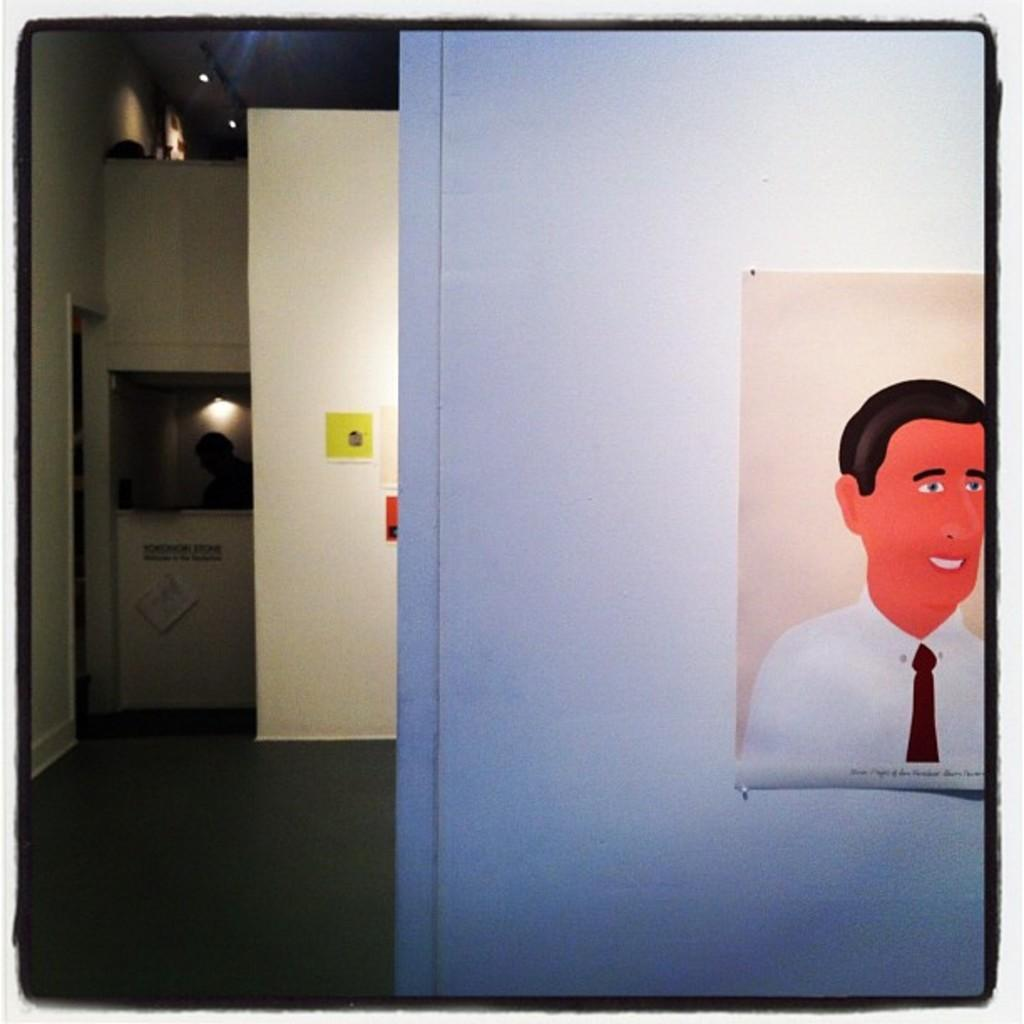What is depicted in the image? There are paintings in the image. What can be seen in the background of the image? There are lights and a person in the background of the image. What type of debt is being discussed in the image? There is no mention of debt in the image; it features paintings, lights, and a person in the background. 